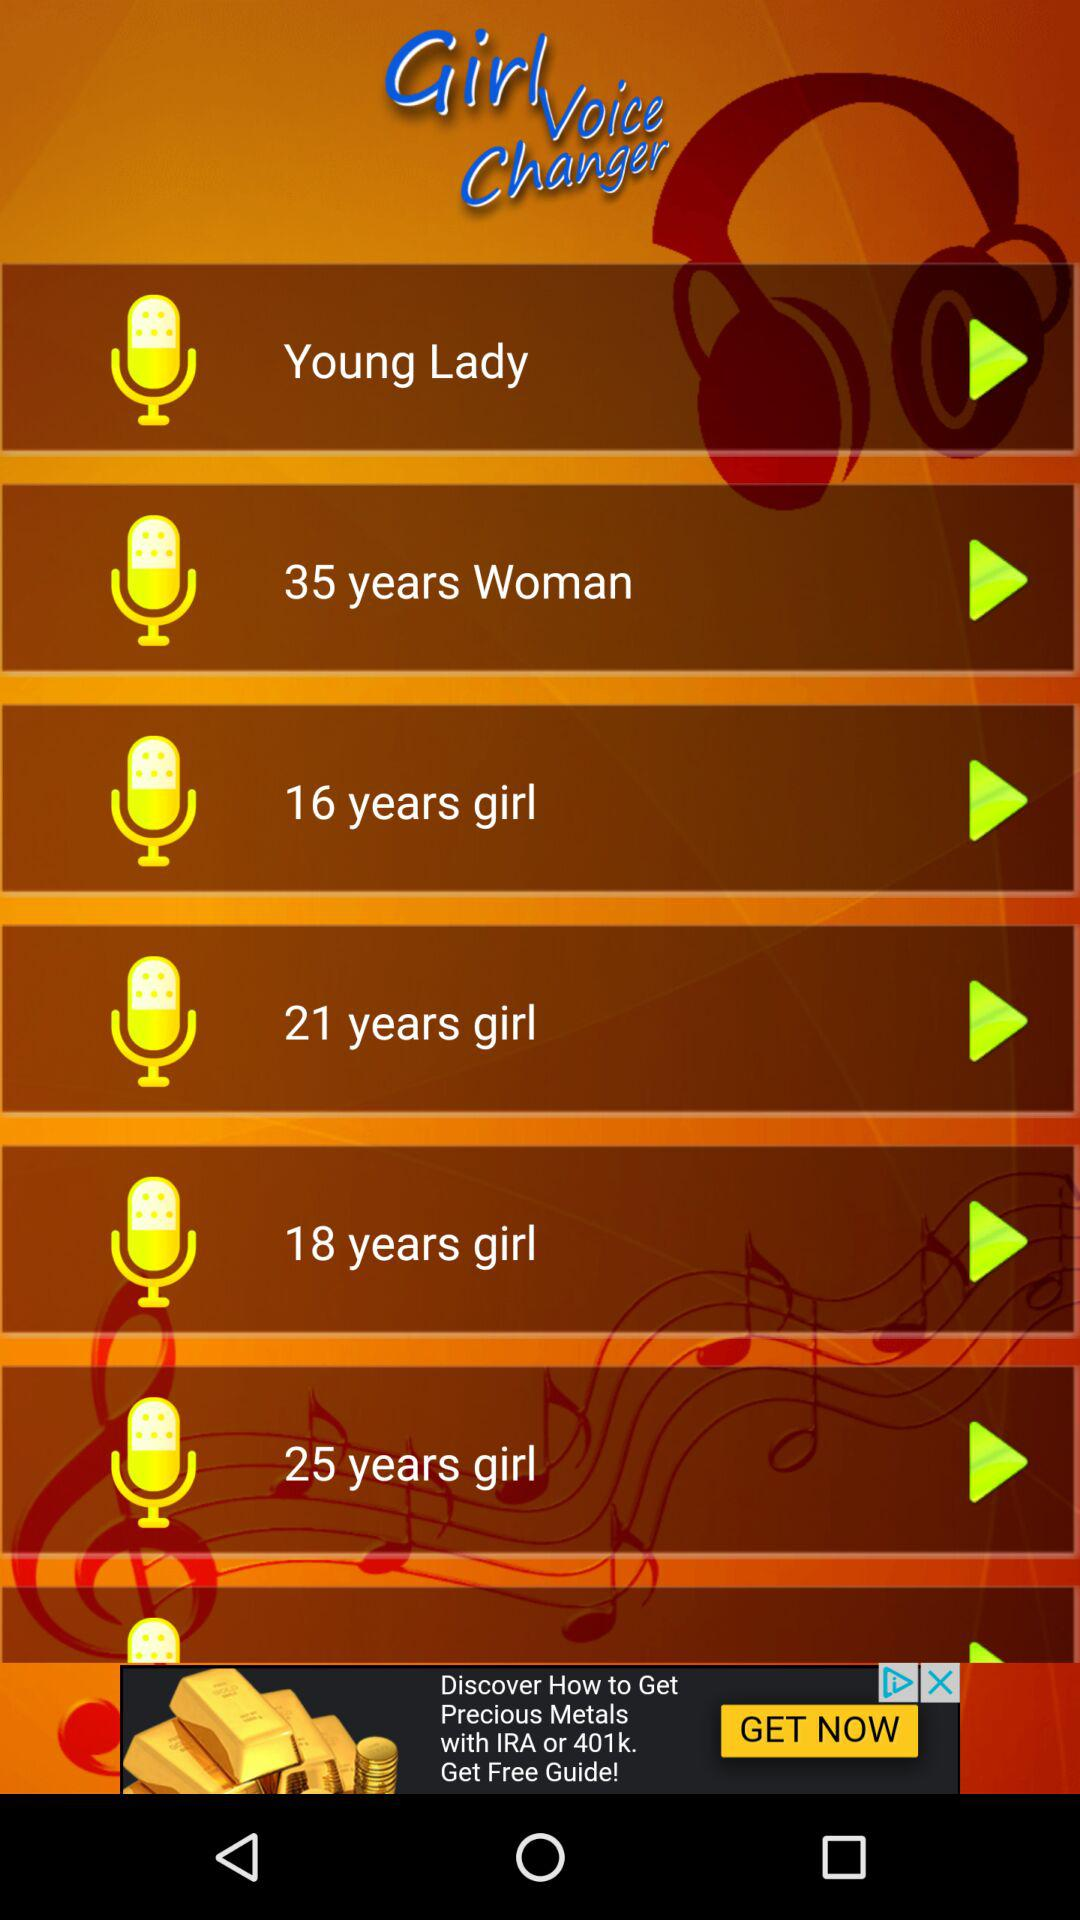How many voice options are there for girls who are older than 20 years old?
Answer the question using a single word or phrase. 3 